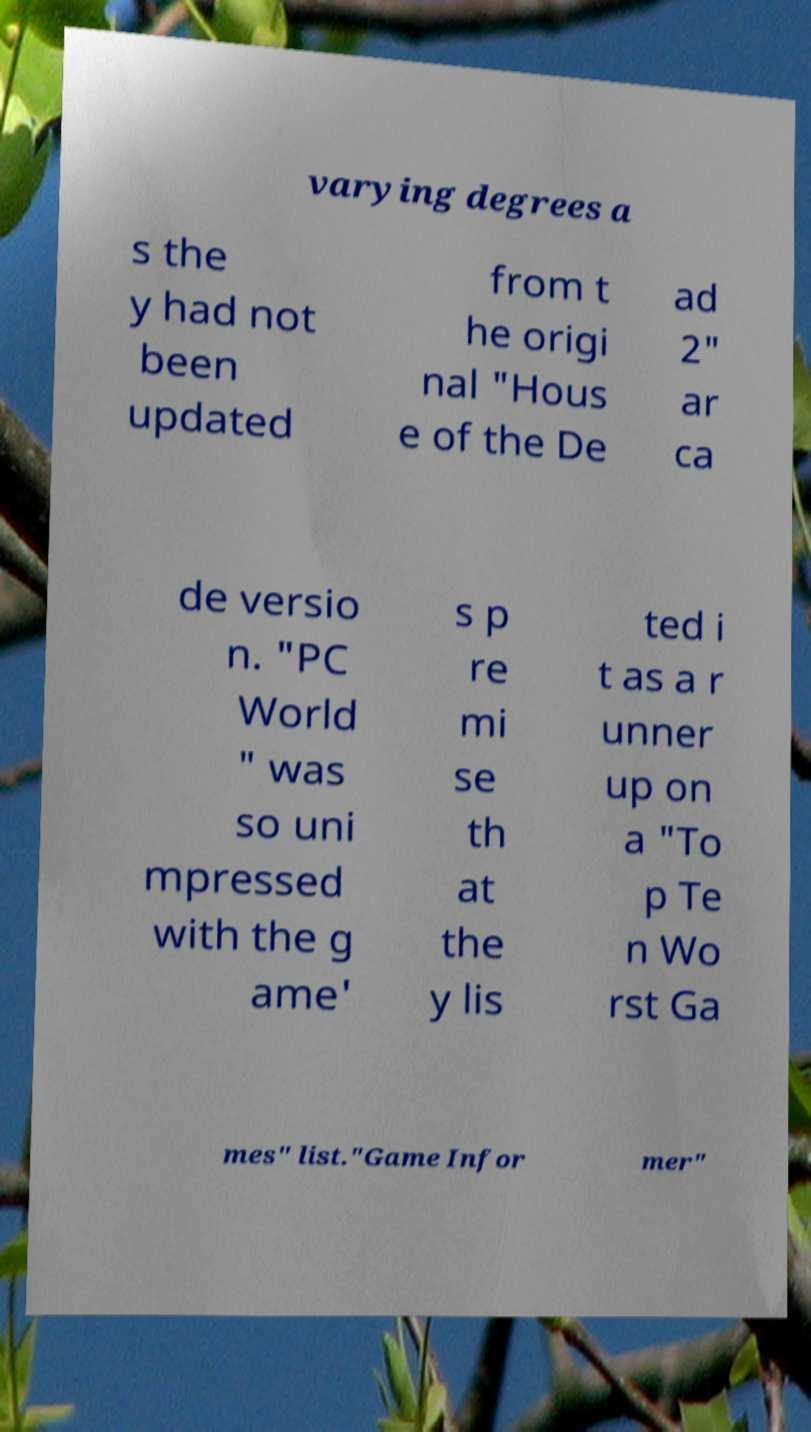Please identify and transcribe the text found in this image. varying degrees a s the y had not been updated from t he origi nal "Hous e of the De ad 2" ar ca de versio n. "PC World " was so uni mpressed with the g ame' s p re mi se th at the y lis ted i t as a r unner up on a "To p Te n Wo rst Ga mes" list."Game Infor mer" 